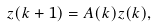Convert formula to latex. <formula><loc_0><loc_0><loc_500><loc_500>z ( k + 1 ) = A ( k ) z ( k ) ,</formula> 